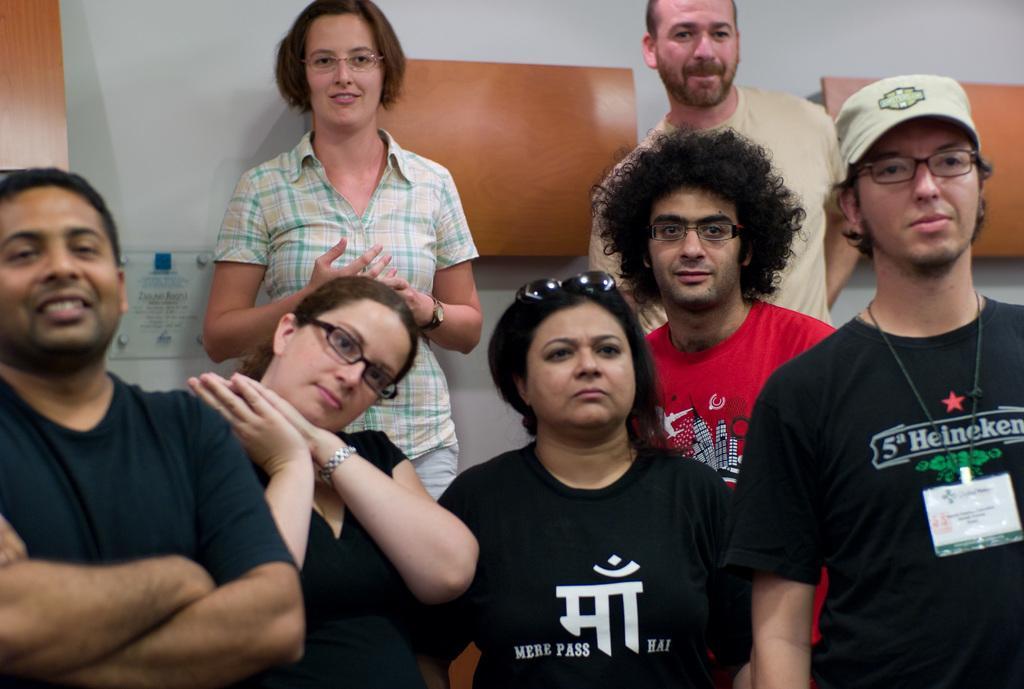Could you give a brief overview of what you see in this image? In this image in front there are people. Behind them there is a wall. There are wooden boards. 